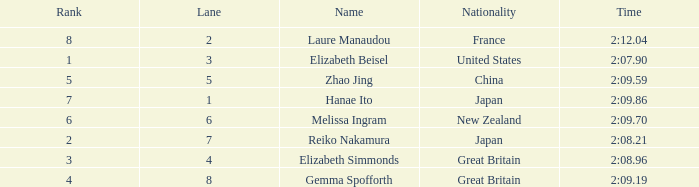What is Laure Manaudou's highest rank? 8.0. 